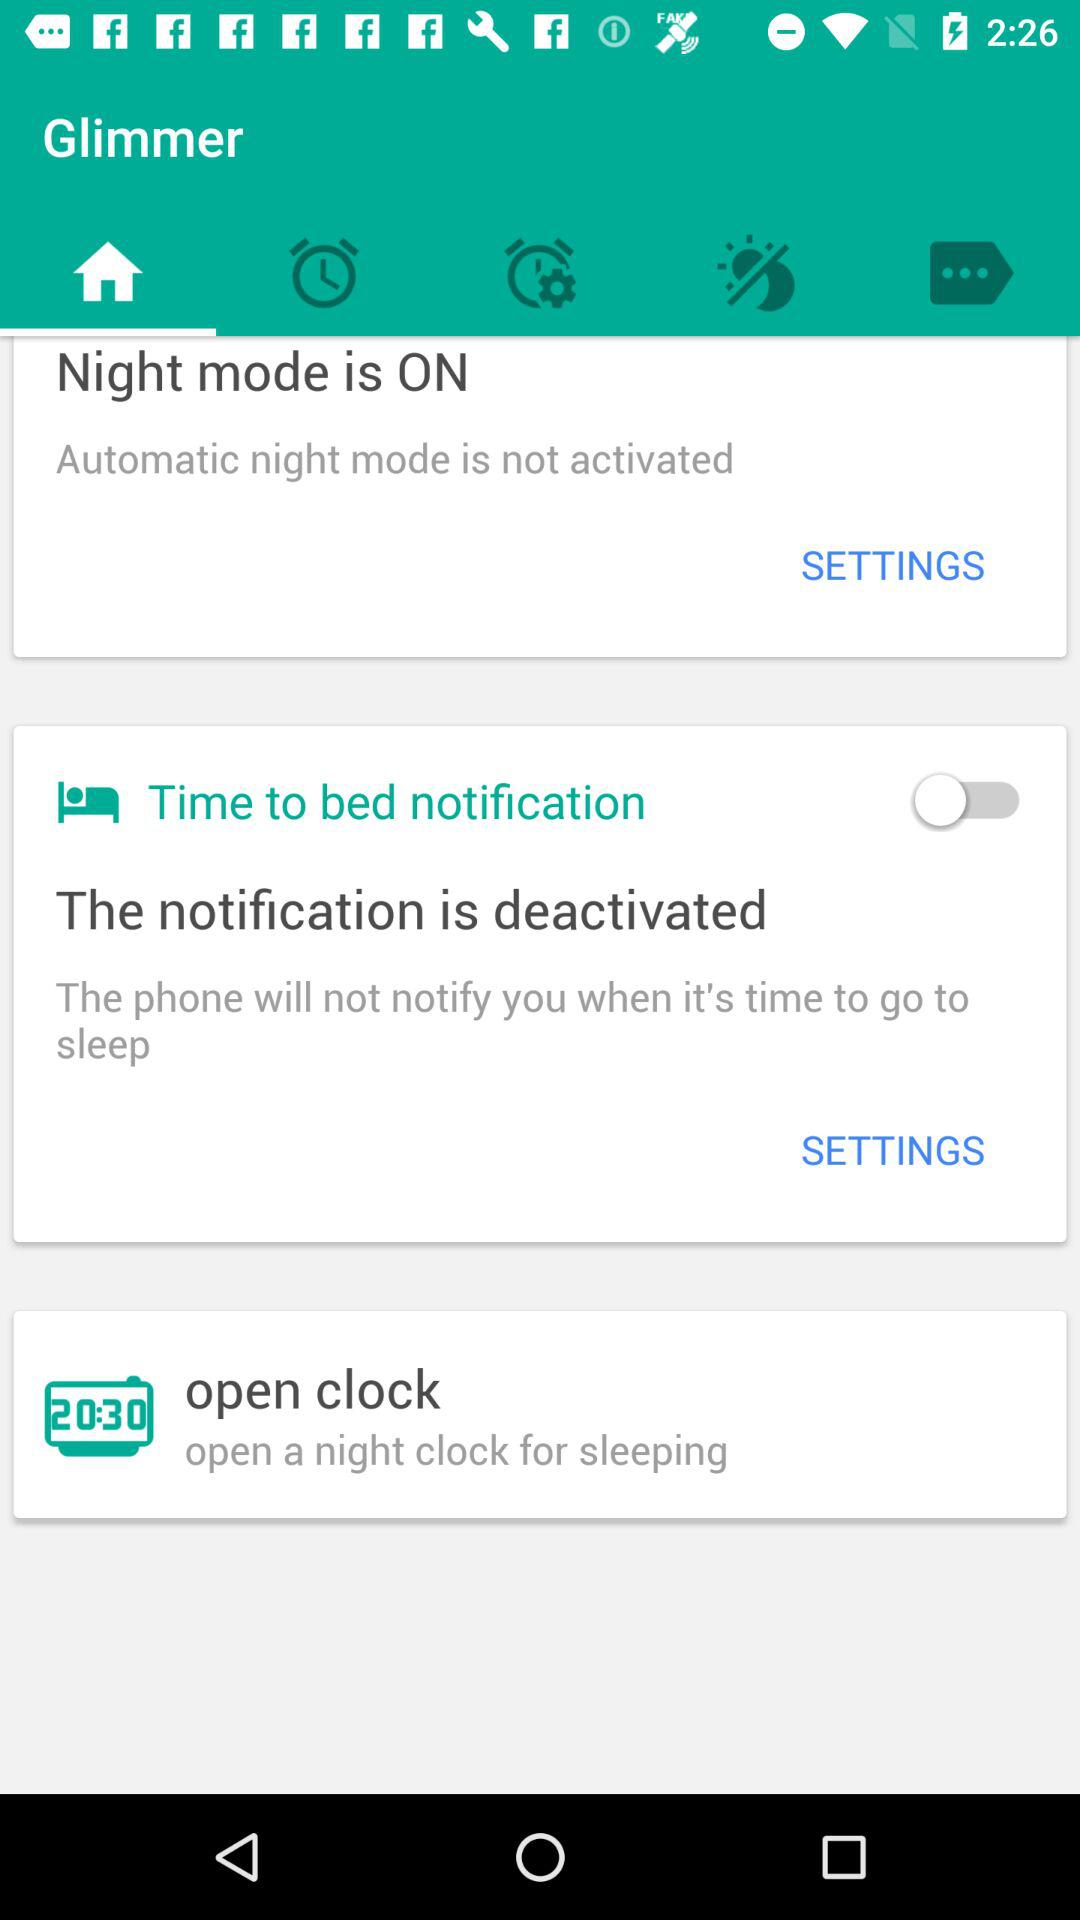What is the application name? The application name is "Glimmer". 